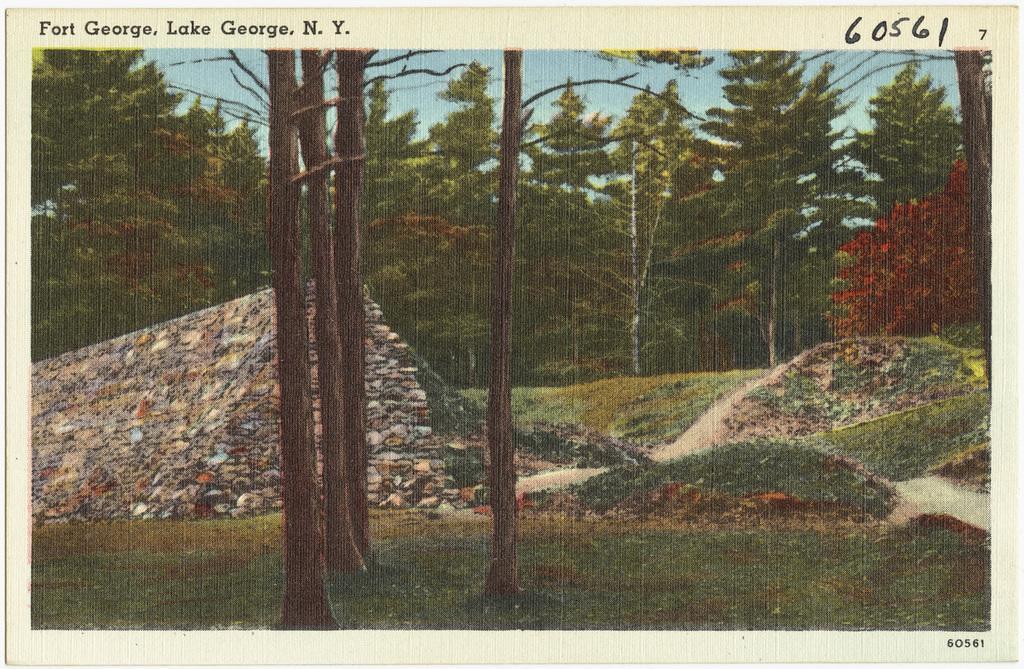In one or two sentences, can you explain what this image depicts? In this picture there are four tree trunks and there are trees in the background and there is something written above it. 